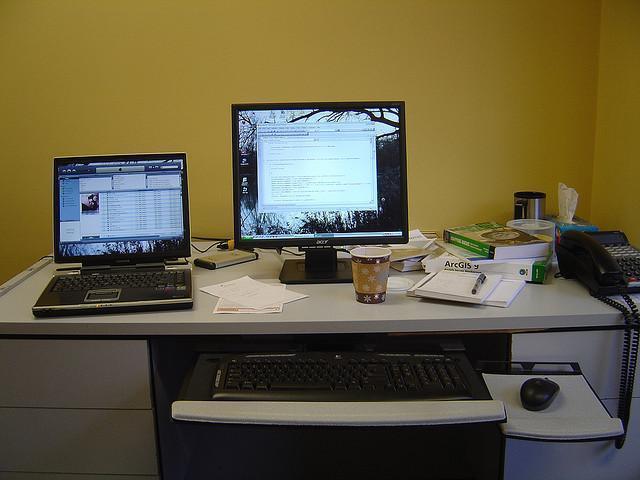Why would someone sit here?
Make your selection from the four choices given to correctly answer the question.
Options: To work, to paint, to wait, to eat. To work. 